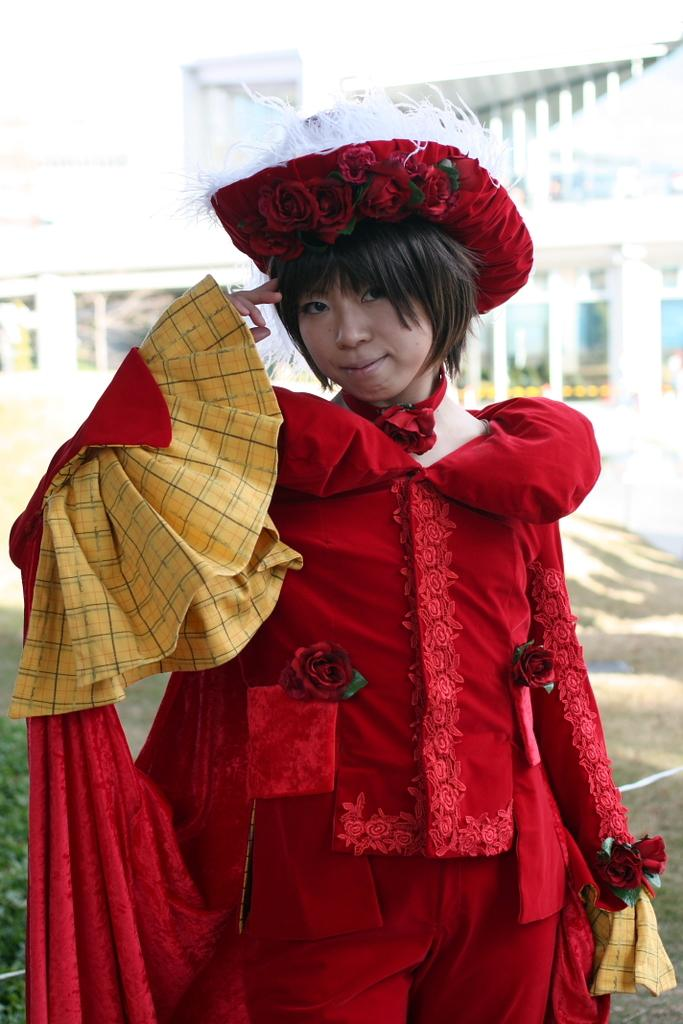Who is present in the image? There is a woman in the image. What is the woman doing in the image? The woman is standing in the image. What is the woman wearing in the image? The woman is wearing a red dress in the image. What can be seen in the background of the image? There is a building in the background of the image. What type of apparatus is the woman using to communicate with the visitor in the image? There is no apparatus or visitor present in the image; it only features a woman standing in a red dress with a building in the background. 